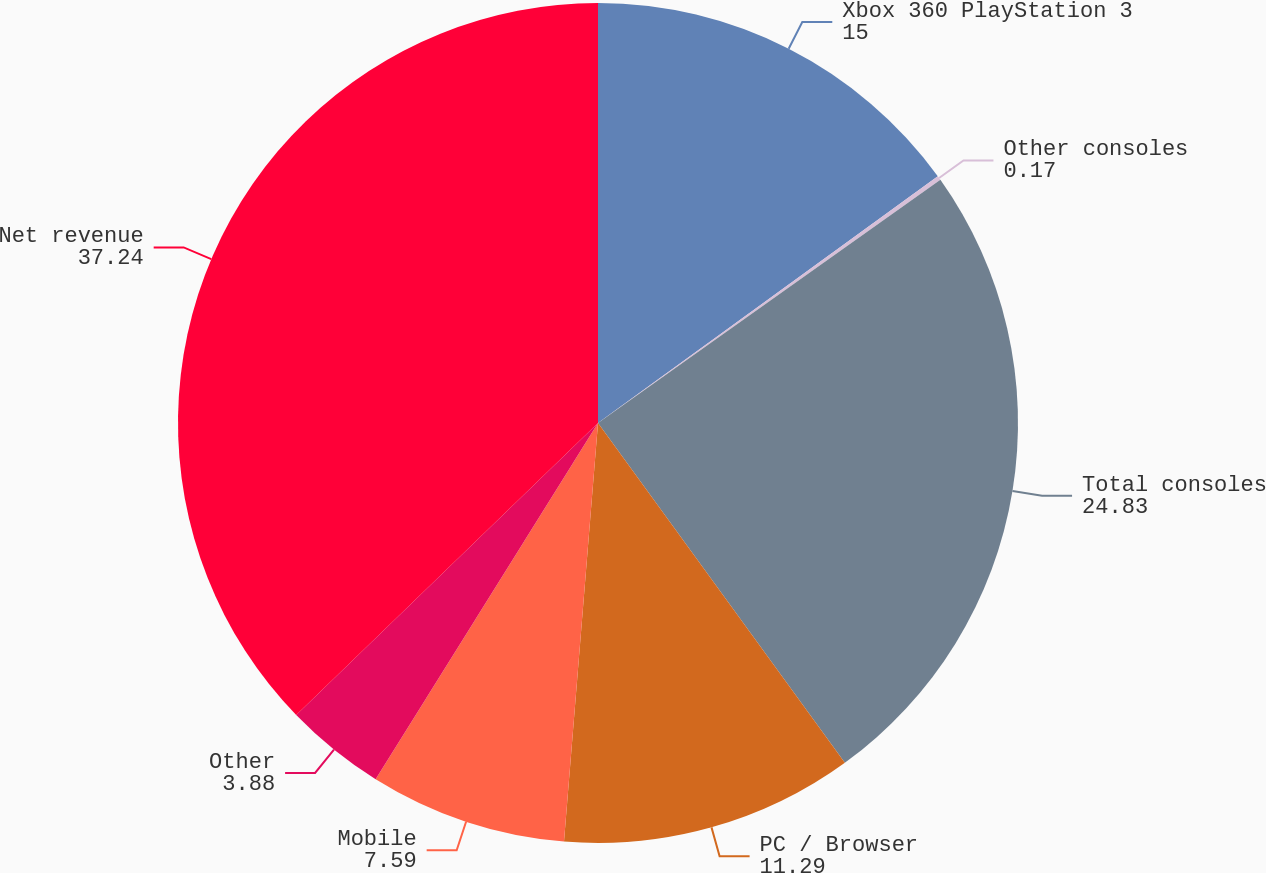<chart> <loc_0><loc_0><loc_500><loc_500><pie_chart><fcel>Xbox 360 PlayStation 3<fcel>Other consoles<fcel>Total consoles<fcel>PC / Browser<fcel>Mobile<fcel>Other<fcel>Net revenue<nl><fcel>15.0%<fcel>0.17%<fcel>24.83%<fcel>11.29%<fcel>7.59%<fcel>3.88%<fcel>37.24%<nl></chart> 